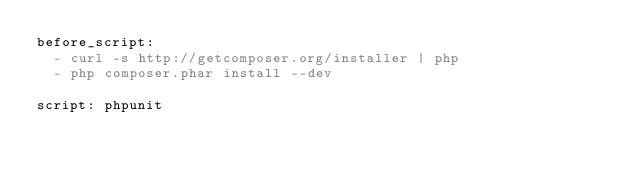<code> <loc_0><loc_0><loc_500><loc_500><_YAML_>before_script:
  - curl -s http://getcomposer.org/installer | php
  - php composer.phar install --dev

script: phpunit
</code> 